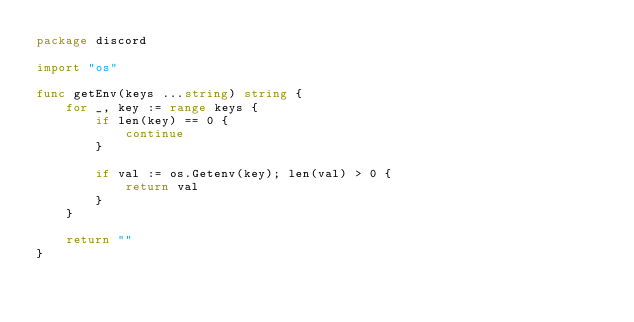<code> <loc_0><loc_0><loc_500><loc_500><_Go_>package discord

import "os"

func getEnv(keys ...string) string {
	for _, key := range keys {
		if len(key) == 0 {
			continue
		}

		if val := os.Getenv(key); len(val) > 0 {
			return val
		}
	}

	return ""
}
</code> 